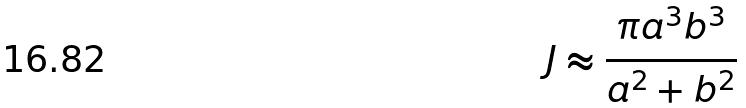Convert formula to latex. <formula><loc_0><loc_0><loc_500><loc_500>J \approx \frac { \pi a ^ { 3 } b ^ { 3 } } { a ^ { 2 } + b ^ { 2 } }</formula> 